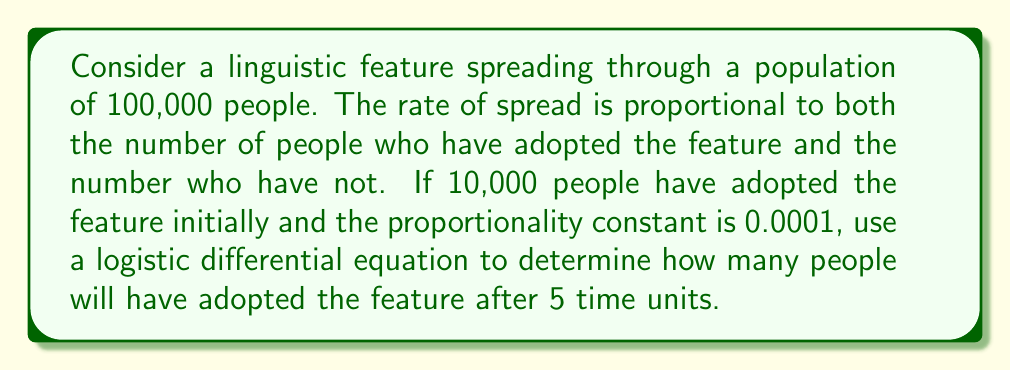Help me with this question. Let's approach this step-by-step:

1) Let $P(t)$ be the number of people who have adopted the feature at time $t$.

2) The logistic differential equation for this scenario is:

   $$\frac{dP}{dt} = kP(N-P)$$

   where $k$ is the proportionality constant, and $N$ is the total population.

3) We're given:
   - $N = 100,000$
   - $P(0) = 10,000$ (initial condition)
   - $k = 0.0001$

4) The solution to this differential equation is:

   $$P(t) = \frac{N}{1 + (\frac{N}{P_0} - 1)e^{-kNt}}$$

   where $P_0$ is the initial population with the feature.

5) Substituting our values:

   $$P(t) = \frac{100,000}{1 + (\frac{100,000}{10,000} - 1)e^{-0.0001 \cdot 100,000 \cdot t}}$$

6) Simplify:

   $$P(t) = \frac{100,000}{1 + 9e^{-10t}}$$

7) We want to find $P(5)$, so let's substitute $t=5$:

   $$P(5) = \frac{100,000}{1 + 9e^{-50}}$$

8) Calculate:

   $$P(5) \approx 90,479.7$$

9) Since we're dealing with people, we round to the nearest whole number.
Answer: After 5 time units, approximately 90,480 people will have adopted the linguistic feature. 